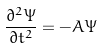<formula> <loc_0><loc_0><loc_500><loc_500>\frac { \partial ^ { 2 } \Psi } { \partial t ^ { 2 } } = - A \Psi</formula> 